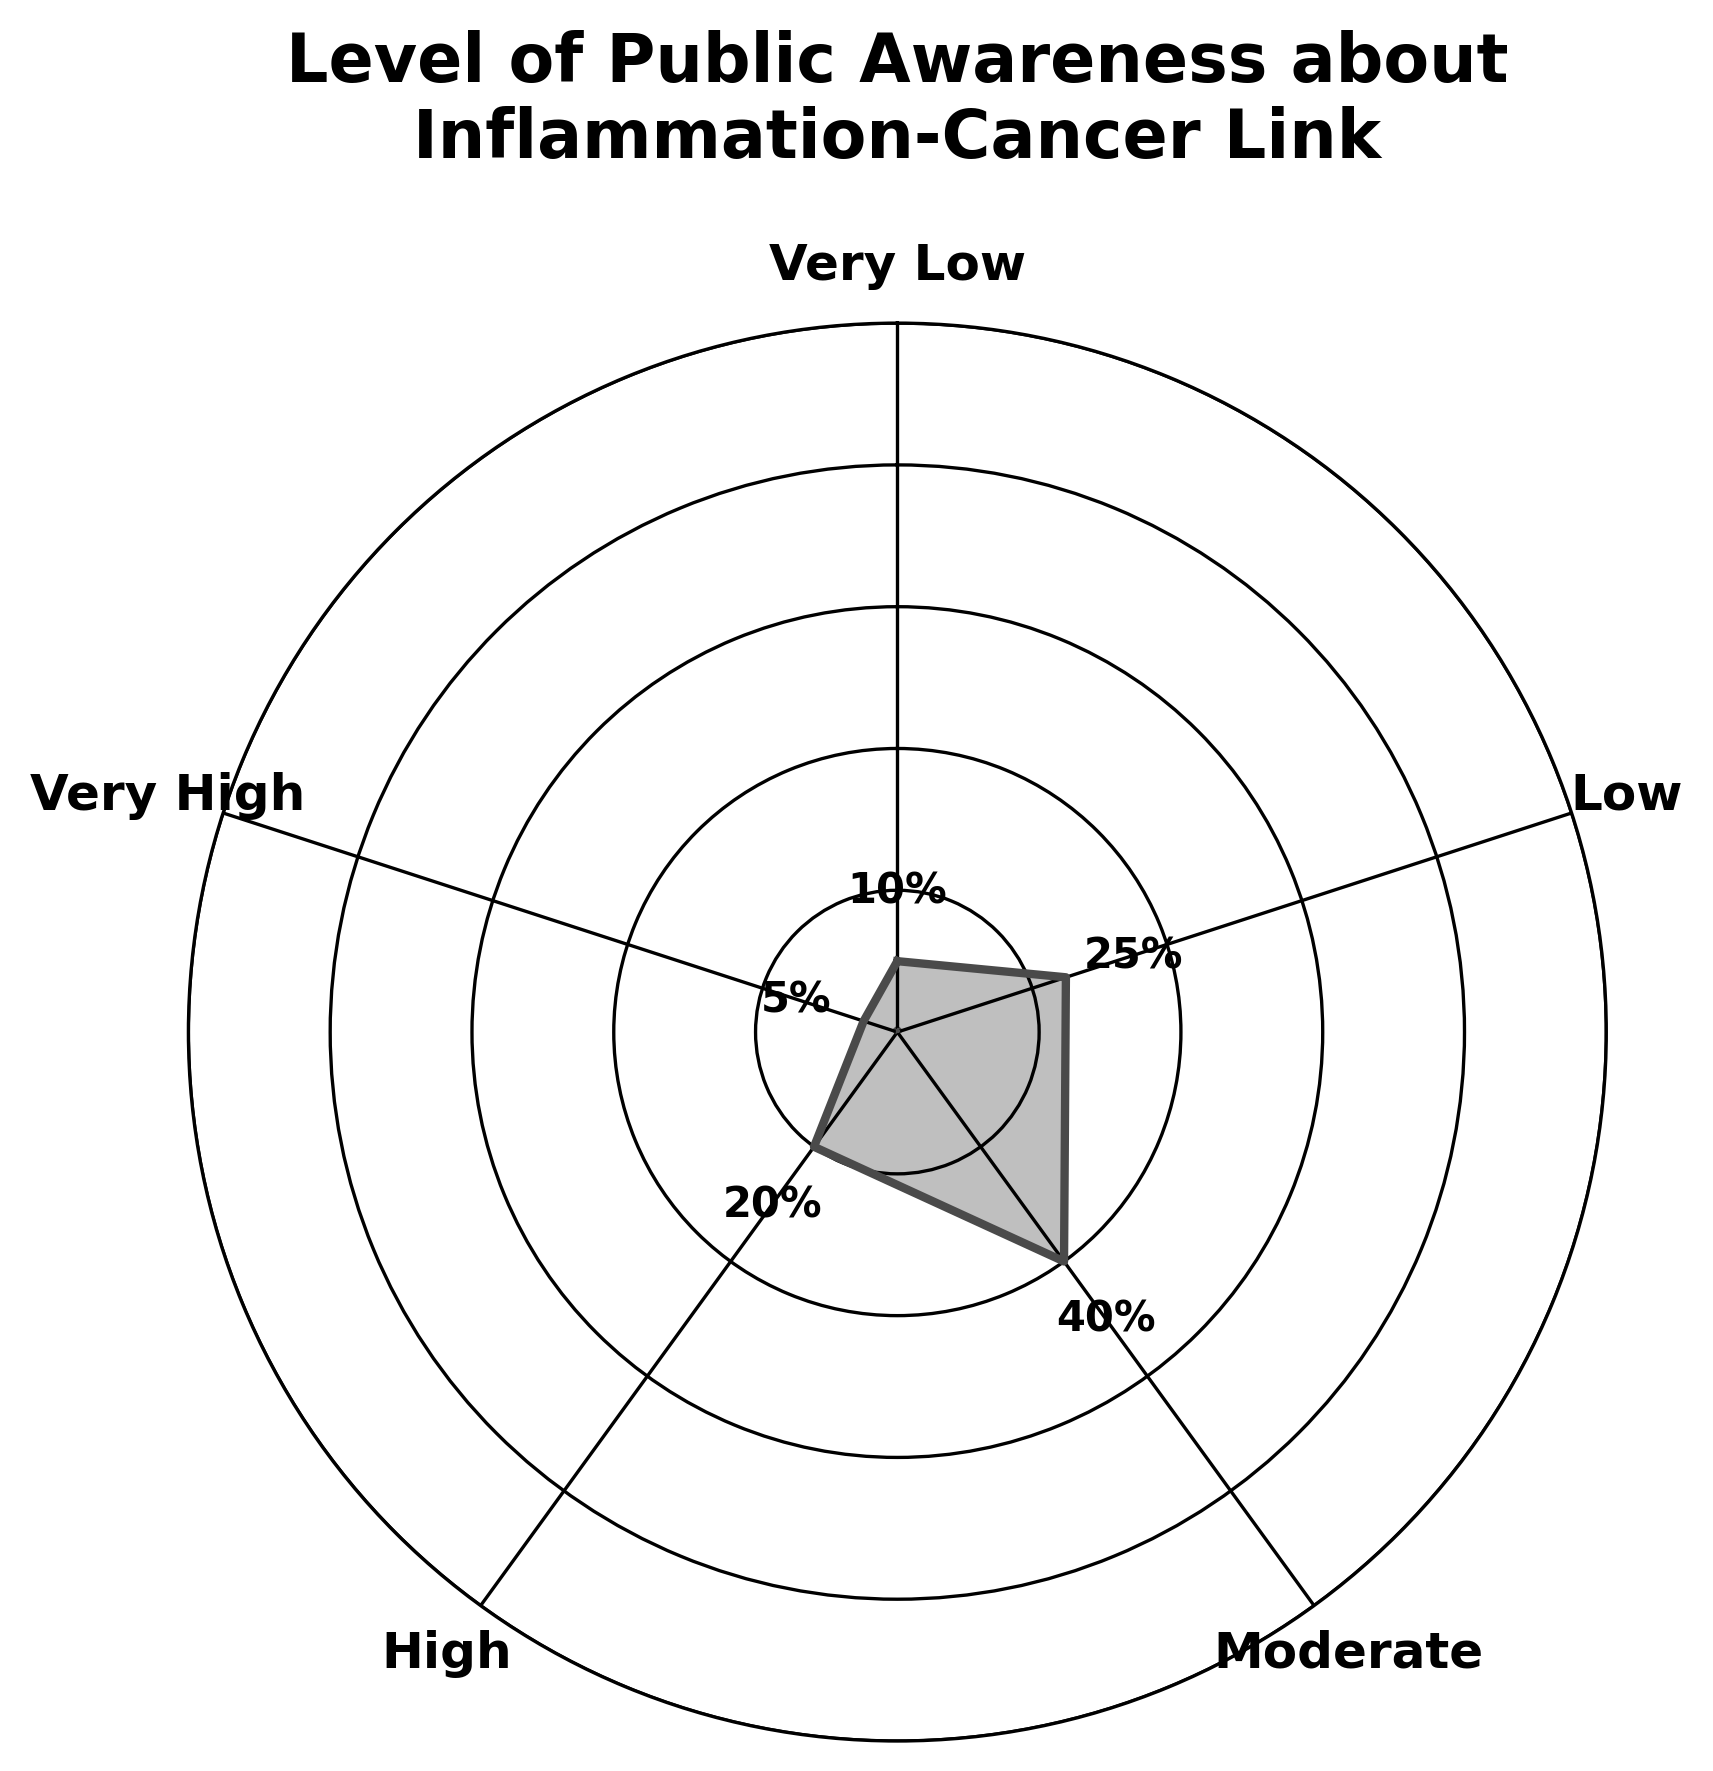What is the title of the figure? The title is usually displayed prominently at the top of the figure. Here it states the main subject of the chart.
Answer: Level of Public Awareness about Inflammation-Cancer Link How many distinct awareness levels are represented in the chart? Count the number of categories listed around the polar plot. Each category represents a different awareness level.
Answer: 5 Which awareness level has the highest percentage? Look for the label with the highest value around the chart. This is represented by the distance from the center.
Answer: Moderate What is the percentage of public awareness categorized as "Very High"? Identify the specific segment labeled "Very High" and read off the percentage value next to it.
Answer: 5% How does the percentage of "Low" awareness compare to "High" awareness? Check the percentage values for both "Low" and "High" awareness and compare the two. The "Low" segment is larger by percentage.
Answer: Low is 5% higher than High What is the average percentage of public awareness across all categories? Sum up the percentages (10 + 25 + 40 + 20 + 5) and divide by the number of categories (5) to find the average.
Answer: 20% Which awareness level is closest to the average percentage? Compare each category’s percentage to the calculated average (20%). Look for the value that is closest.
Answer: High What is the combined percentage of "Very Low" and "Very High" awareness levels? Add the percentages of these two categories (10% and 5%) together to find the combined value.
Answer: 15% Is the percentage of "Moderate" awareness greater than the combined percentage of "Very Low" and "Very High"? Compare the percentage of "Moderate" awareness (40%) with the summed value of "Very Low" and "Very High" (15%).
Answer: Yes What does the needle in the center of the figure represent? The needle generally indicates an average or central value derived from the data, here it demonstrates the average level of awareness.
Answer: Average awareness level 